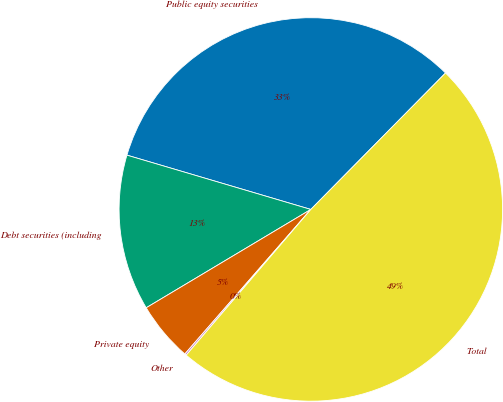Convert chart. <chart><loc_0><loc_0><loc_500><loc_500><pie_chart><fcel>Public equity securities<fcel>Debt securities (including<fcel>Private equity<fcel>Other<fcel>Total<nl><fcel>32.83%<fcel>13.14%<fcel>5.02%<fcel>0.15%<fcel>48.86%<nl></chart> 